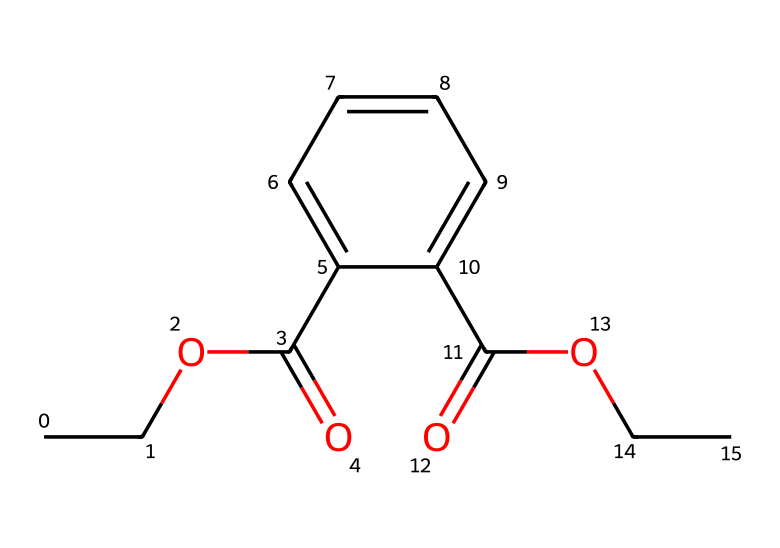What is the primary functional group present in this chemical? The SMILES representation indicates the presence of a carboxylic acid functional group, which is identified by the "C(=O)O" segment. This portion showcases the carbonyl (C=O) and hydroxyl (O) components typical of carboxylic acids.
Answer: carboxylic acid How many oxygen atoms are present in this chemical structure? By analyzing the SMILES representation, we can count the oxygen atoms represented. There are two "O" atoms in the carboxylic acid group and one in the ester section, resulting in a total of three oxygen atoms.
Answer: three What type of polymer can be derived from this monomer? This chemical is a type of phthalate based monomer, which can polymerize into polyesters due to the presence of both ester linkages and carboxylic functional group. These polymer structures have applications in various materials.
Answer: polyester How many carbon atoms are in this chemical? Counting the carbon "C" symbols in the SMILES representation, including those in the aromatic ring and the aliphatic portion, yields a total of eleven carbon atoms within the structure.
Answer: eleven Does this chemical contain aromatic rings? Upon inspection of the SMILES representation, the "c" letters indicate aromatic carbons, which signify the presence of benzene rings in the structure. Therefore, this chemical does indeed have aromatic components.
Answer: yes What type of reaction would this monomer play a role in to form a polymer? The esterification reaction is applicable here, as the chemical structure contains both an alcohol and a carboxylic acid component that can react to form ester linkages, thus leading towards polymer formation.
Answer: esterification 